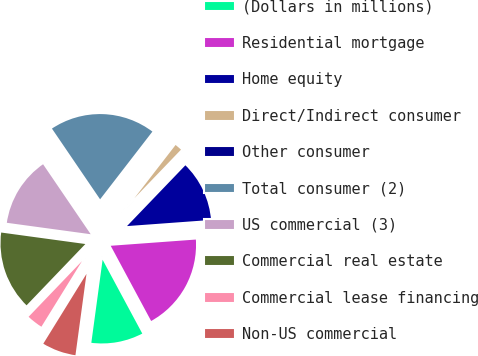<chart> <loc_0><loc_0><loc_500><loc_500><pie_chart><fcel>(Dollars in millions)<fcel>Residential mortgage<fcel>Home equity<fcel>Direct/Indirect consumer<fcel>Other consumer<fcel>Total consumer (2)<fcel>US commercial (3)<fcel>Commercial real estate<fcel>Commercial lease financing<fcel>Non-US commercial<nl><fcel>10.0%<fcel>18.31%<fcel>11.66%<fcel>1.69%<fcel>0.02%<fcel>19.98%<fcel>13.33%<fcel>14.99%<fcel>3.35%<fcel>6.67%<nl></chart> 